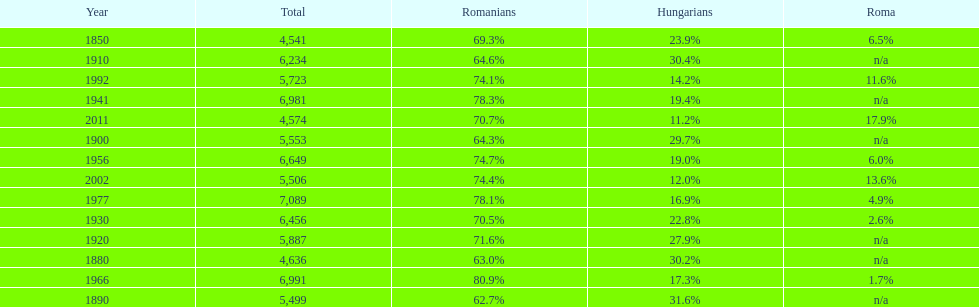What were the total number of times the romanians had a population percentage above 70%? 9. 